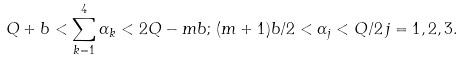<formula> <loc_0><loc_0><loc_500><loc_500>Q + b < \sum _ { k = 1 } ^ { 4 } \alpha _ { k } < 2 Q - m b ; \, ( m + 1 ) b / 2 < \alpha _ { j } < Q / 2 \, j = 1 , 2 , 3 .</formula> 